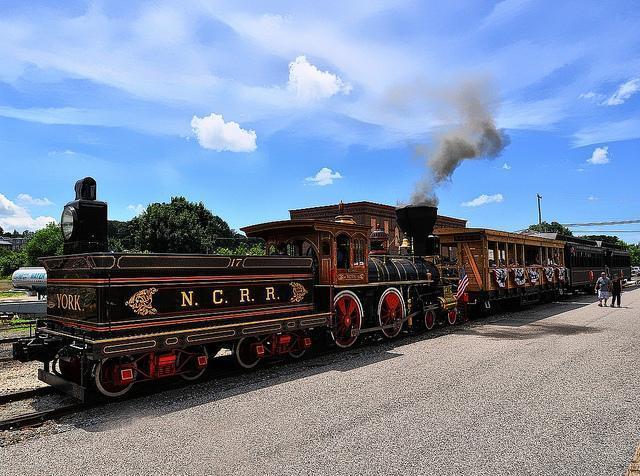How many vases are here?
Give a very brief answer. 0. 